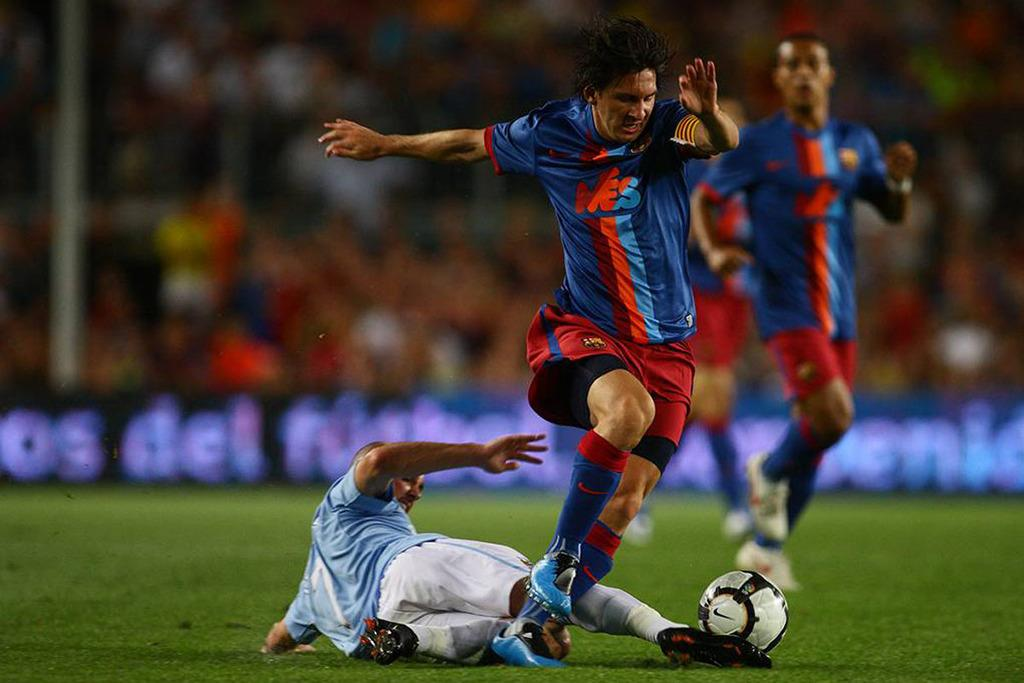Who or what can be seen in the image? There are people in the image. What are the people doing in the image? The people are playing on the ground. What object is associated with their play in the image? There is a football in the image. What type of surface is the ground covered with? The ground is covered with grass. What type of plants can be seen growing on the owl in the image? There is no owl present in the image, and therefore no plants growing on it. 